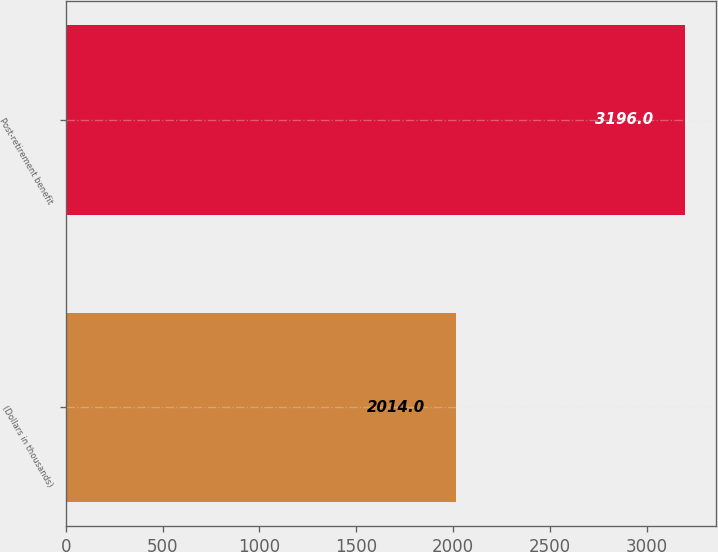Convert chart. <chart><loc_0><loc_0><loc_500><loc_500><bar_chart><fcel>(Dollars in thousands)<fcel>Post-retirement benefit<nl><fcel>2014<fcel>3196<nl></chart> 